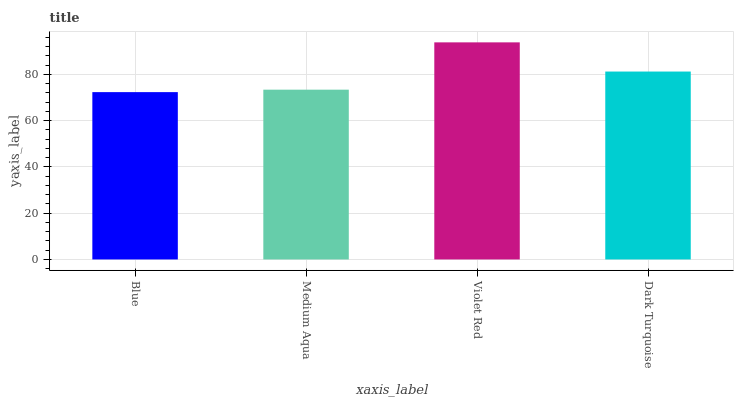Is Blue the minimum?
Answer yes or no. Yes. Is Violet Red the maximum?
Answer yes or no. Yes. Is Medium Aqua the minimum?
Answer yes or no. No. Is Medium Aqua the maximum?
Answer yes or no. No. Is Medium Aqua greater than Blue?
Answer yes or no. Yes. Is Blue less than Medium Aqua?
Answer yes or no. Yes. Is Blue greater than Medium Aqua?
Answer yes or no. No. Is Medium Aqua less than Blue?
Answer yes or no. No. Is Dark Turquoise the high median?
Answer yes or no. Yes. Is Medium Aqua the low median?
Answer yes or no. Yes. Is Violet Red the high median?
Answer yes or no. No. Is Blue the low median?
Answer yes or no. No. 